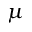Convert formula to latex. <formula><loc_0><loc_0><loc_500><loc_500>\mu</formula> 